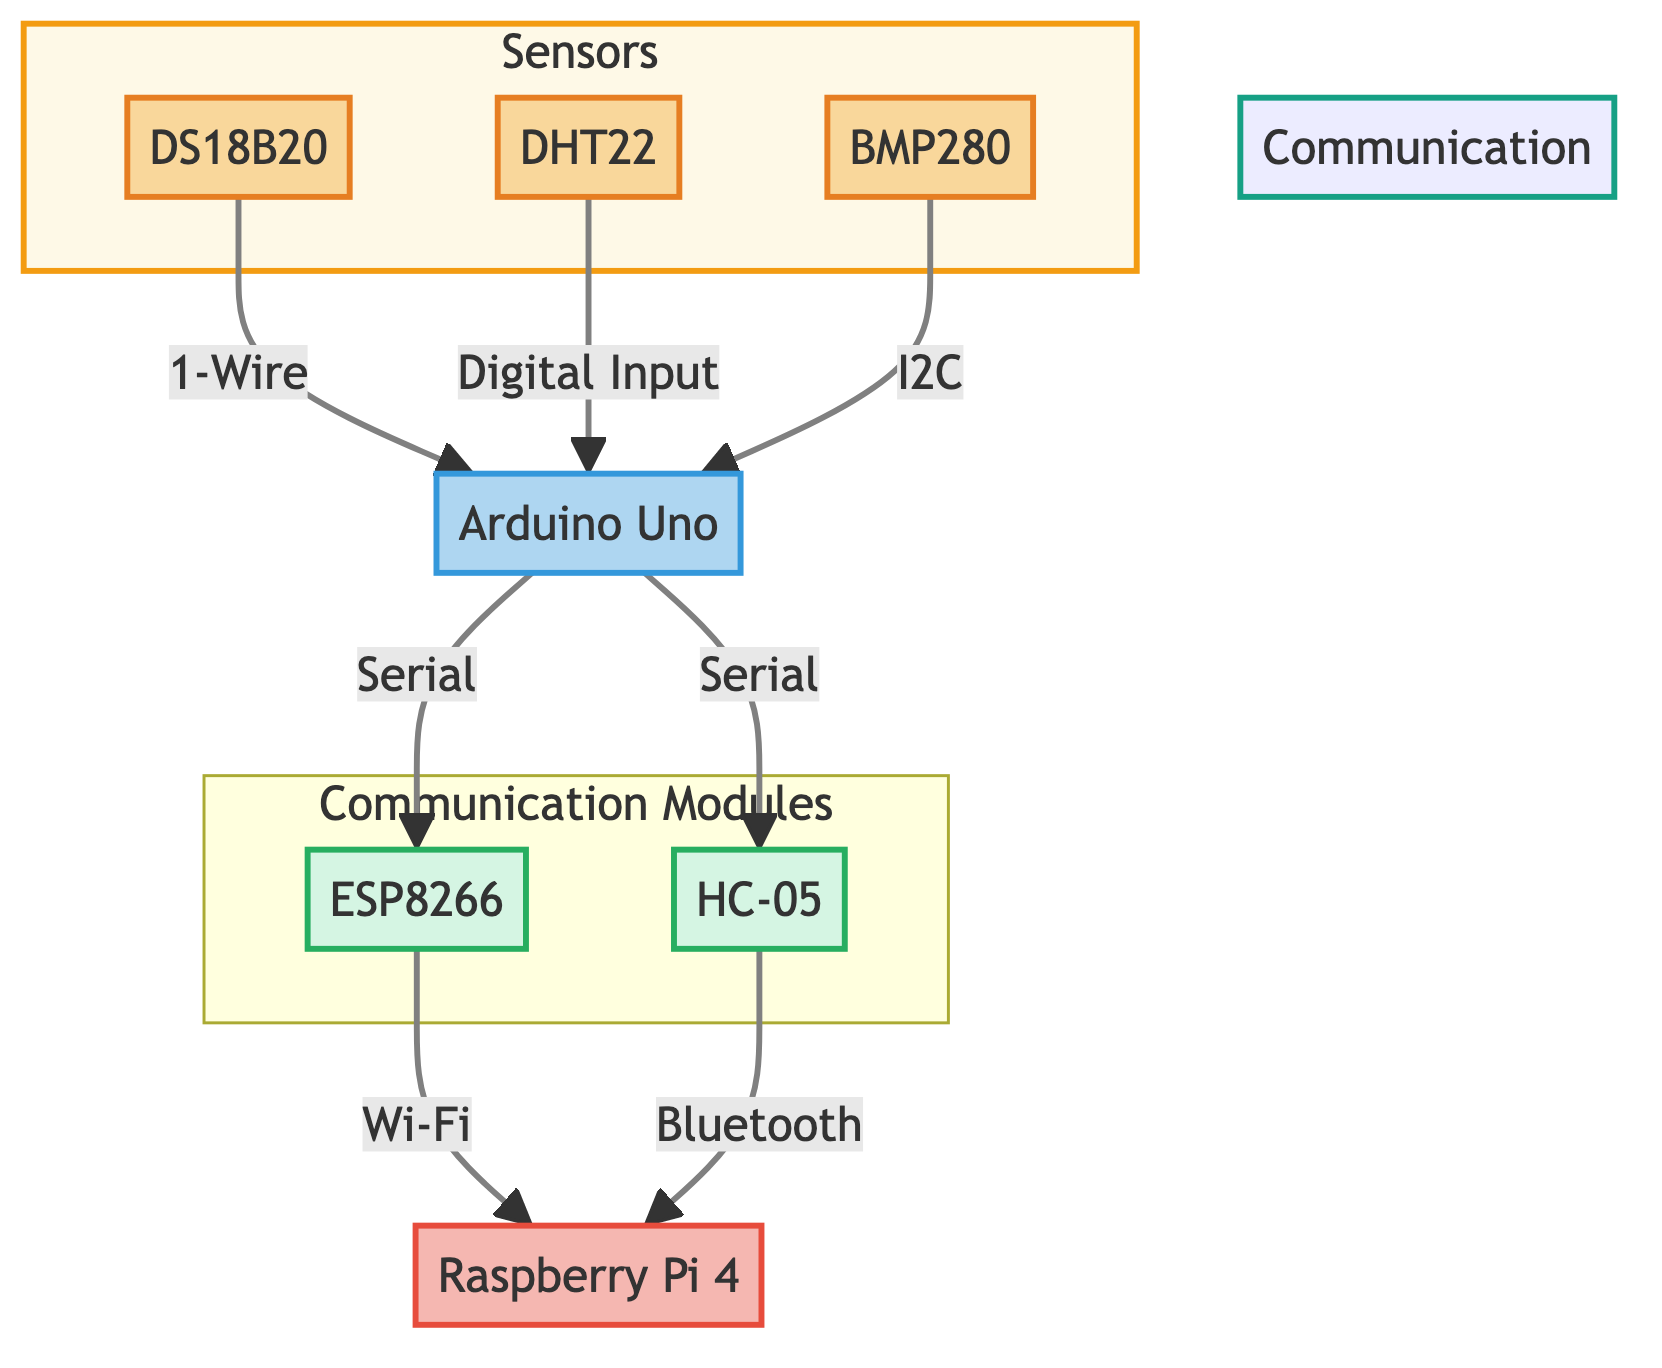What is the central unit in the diagram? The central unit is designated clearly in the diagram as "Raspberry Pi 4." This can be identified as it has a distinct color and label highlighting its role in the communication flow.
Answer: Raspberry Pi 4 How many types of sensors are shown in the diagram? In the diagram, there are three types of sensors listed: DS18B20, DHT22, and BMP280. Each sensor is represented in its own labeled node, confirming their presence.
Answer: 3 Which protocol is used for data transmission from the BMP280 to the Arduino Uno? The diagram indicates that the connection from BMP280 to Arduino Uno happens via the "I2C" protocol. This is shown utilizing an arrow that labels the connection accordingly.
Answer: I2C What communication module is used for Bluetooth transmission? The diagram specifies "HC-05" as the communication module used for Bluetooth transmission. This is clearly labeled and indicates its function within the network.
Answer: HC-05 Which sensor has a connection via Digital Input to the Arduino? The DHT22 sensor is the one that connects to the Arduino Uno using the Digital Input protocol, as stated in the labeled flow in the diagram.
Answer: DHT22 What is the flow direction from the Arduino Uno to the communication modules? The flow direction is indicated with arrows from the Arduino Uno to both the ESP8266 and HC-05, both labeled as “Serial.” This shows the relationships and the paths that the data follows.
Answer: Serial How many communication protocols are represented in the diagram? The diagram represents two communication protocols, Wi-Fi and Bluetooth, which are associated with the respective modules ESP8266 and HC-05. The labeling and grouping shows their distinct roles.
Answer: 2 What type of data flow is used to transmit data from DS18B20 to Arduino Uno? The data flow from DS18B20 to the Arduino Uno is via the "1-Wire" protocol, evidenced by the labeling in the diagram that specifically connects these devices.
Answer: 1-Wire 